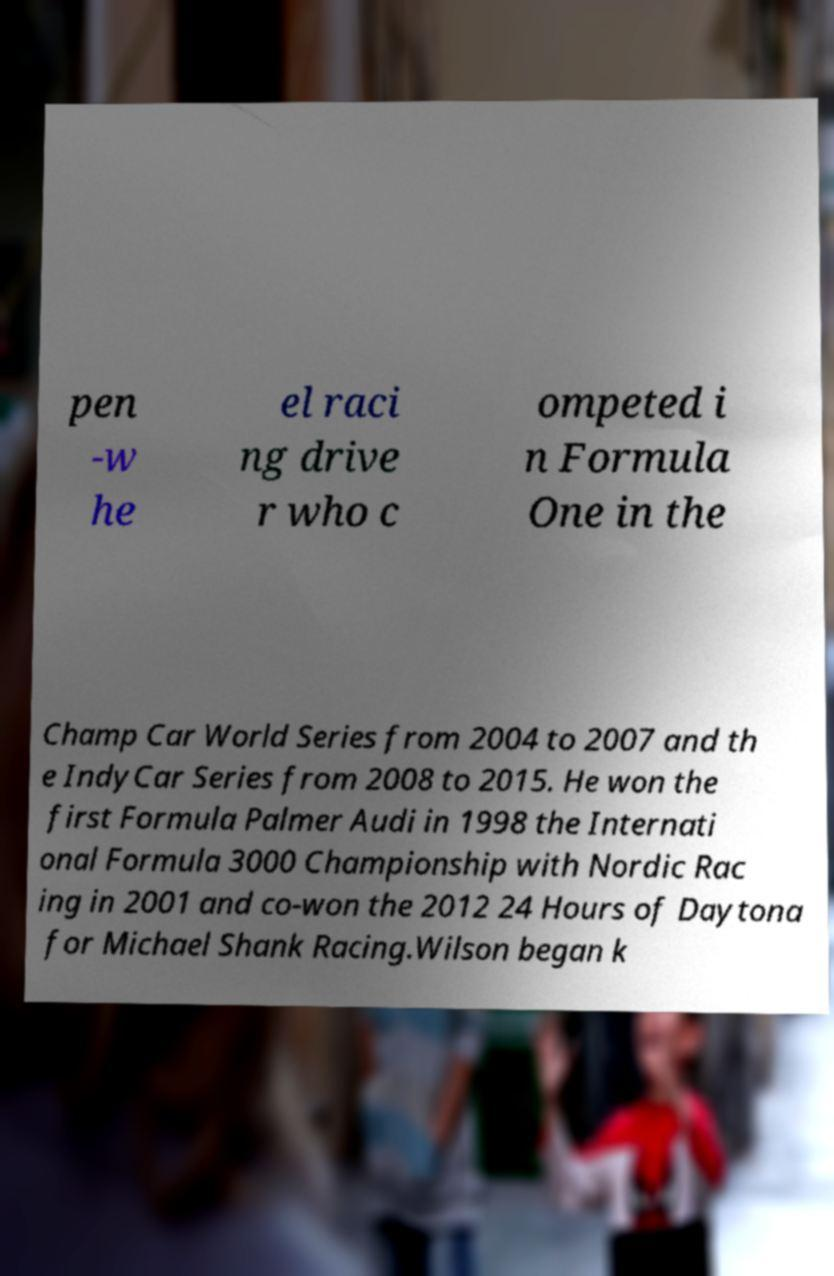Could you assist in decoding the text presented in this image and type it out clearly? pen -w he el raci ng drive r who c ompeted i n Formula One in the Champ Car World Series from 2004 to 2007 and th e IndyCar Series from 2008 to 2015. He won the first Formula Palmer Audi in 1998 the Internati onal Formula 3000 Championship with Nordic Rac ing in 2001 and co-won the 2012 24 Hours of Daytona for Michael Shank Racing.Wilson began k 